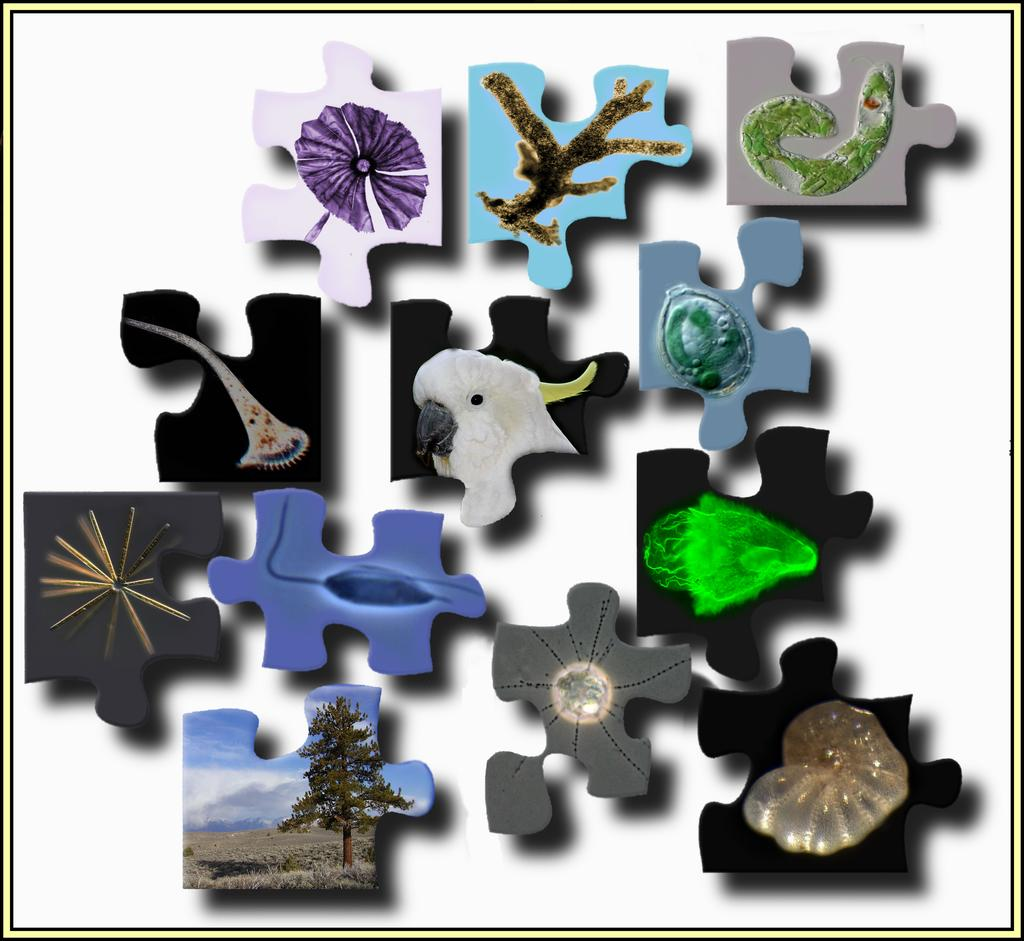What objects are present in the image? There are jigsaw puzzle pieces in the image. Can you describe the surface on which the jigsaw puzzle pieces are placed? The jigsaw puzzle pieces are on a white surface. Can you see any spots on the jigsaw puzzle pieces in the image? There is no mention of spots on the jigsaw puzzle pieces in the image. Is there a flight taking off in the background of the image? There is no reference to a flight or any background in the image; it only features jigsaw puzzle pieces on a white surface. 